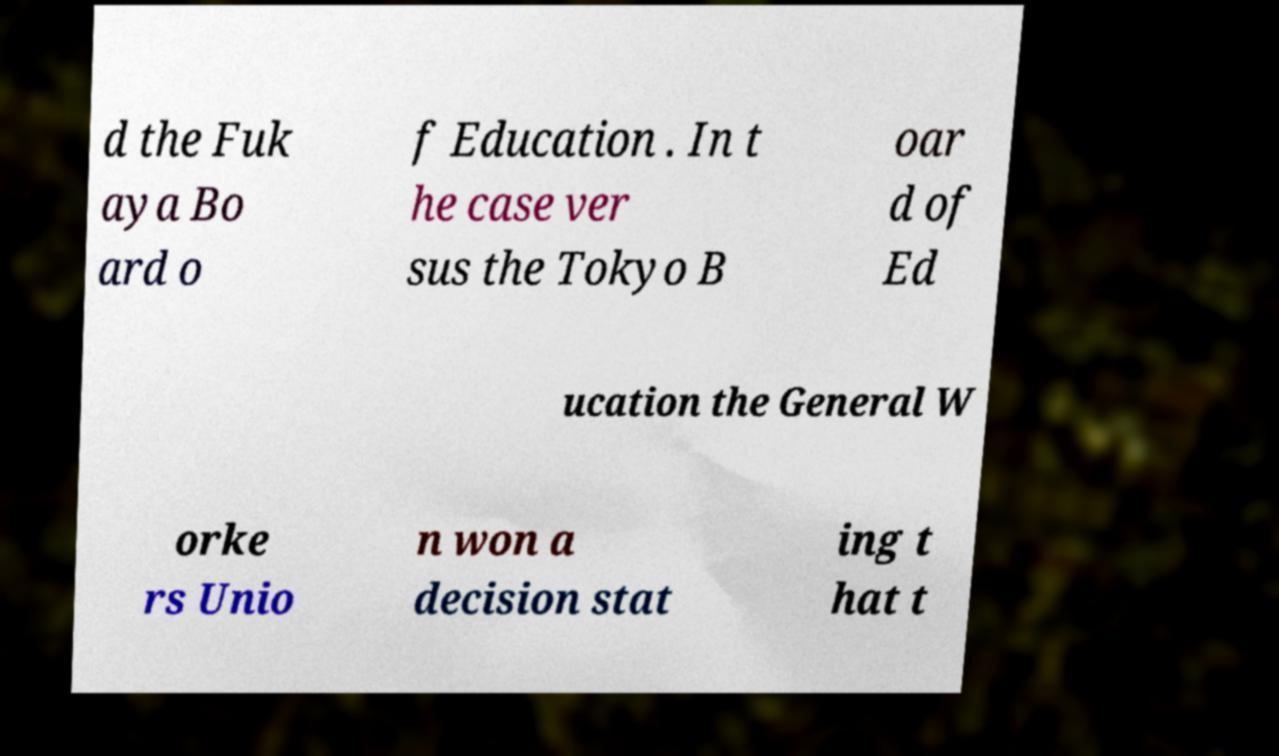Can you accurately transcribe the text from the provided image for me? d the Fuk aya Bo ard o f Education . In t he case ver sus the Tokyo B oar d of Ed ucation the General W orke rs Unio n won a decision stat ing t hat t 